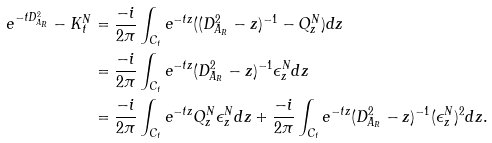Convert formula to latex. <formula><loc_0><loc_0><loc_500><loc_500>e ^ { - t D _ { A _ { R } } ^ { 2 } } - K _ { t } ^ { N } & = \frac { - i } { 2 \pi } \int _ { C _ { t } } e ^ { - t z } ( ( D _ { A _ { R } } ^ { 2 } - z ) ^ { - 1 } - Q ^ { N } _ { z } ) d z \\ & = \frac { - i } { 2 \pi } \int _ { C _ { t } } e ^ { - t z } ( D _ { A _ { R } } ^ { 2 } - z ) ^ { - 1 } \epsilon _ { z } ^ { N } d z \\ & = \frac { - i } { 2 \pi } \int _ { C _ { t } } e ^ { - t z } Q _ { z } ^ { N } \epsilon _ { z } ^ { N } d z + \frac { - i } { 2 \pi } \int _ { C _ { t } } e ^ { - t z } ( D _ { A _ { R } } ^ { 2 } - z ) ^ { - 1 } ( \epsilon _ { z } ^ { N } ) ^ { 2 } d z .</formula> 